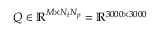<formula> <loc_0><loc_0><loc_500><loc_500>Q \in \mathbb { R } ^ { M \times N _ { t } N _ { p } } = \mathbb { R } ^ { 3 0 0 0 \times 3 0 0 0 }</formula> 